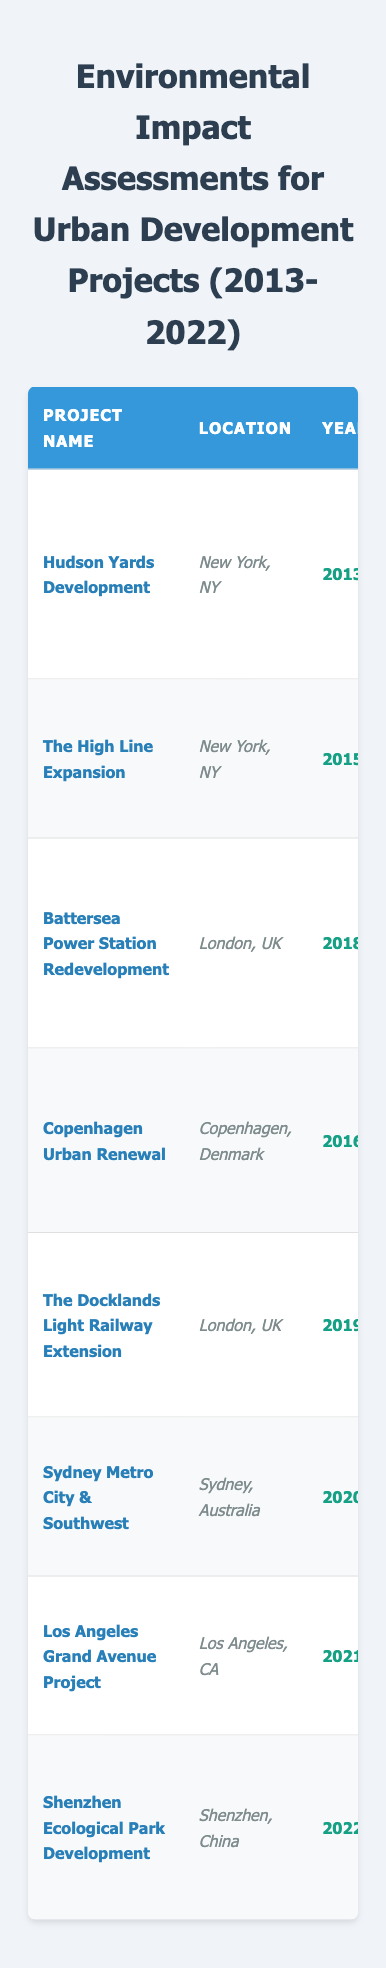What is the location of the Hudson Yards Development project? The table lists the location of each project in the 'Location' column. For the Hudson Yards Development, the location specified is New York, NY.
Answer: New York, NY How many projects assessed noise pollution? By scanning the 'Impact Area' column, I can count the occurrences of "Noise Pollution." This occurs for two projects: Battersea Power Station Redevelopment and Shenzhen Ecological Park Development.
Answer: 2 In which year was the Sydney Metro City & Southwest project completed? The 'Year' column provides the year of completion for each project. The Sydney Metro City & Southwest project was completed in 2020.
Answer: 2020 Did the High Line Expansion project involve public engagement? The 'Public Engagement' column describes the engagement for each project. The High Line Expansion did involve public engagement through an online feedback portal for residents.
Answer: Yes Which stakeholders were involved in the Battersea Power Station Redevelopment project? The 'Stakeholders Involved' column lists the participants for each project. For the Battersea Power Station Redevelopment, stakeholders involved are the Battersea Project Land Company and local government.
Answer: Battersea Project Land Company, local government What mitigation strategy was used in the Los Angeles Grand Avenue Project? The 'Mitigation Strategy' column outlines what strategies were implemented for each project. The strategy for the Los Angeles Grand Avenue Project was to develop a sight lines plan to minimize visual disruption.
Answer: Development of sight lines plan Which project assessment found that construction may lead to increased traffic congestion? The 'Assessment Findings' column indicates the outcomes related to each project. The Docklands Light Railway Extension project indicated improved public transport access but also potential increases in surrounding traffic.
Answer: The Docklands Light Railway Extension What is the total number of projects listed in the table? By counting the number of rows in the table after the header, I find that there are eight projects listed within the table.
Answer: 8 Which project was assessed for its impact on cultural heritage? The 'Impact Area' column lists the areas of impact for each project. The Sydney Metro City & Southwest project was the only project assessed for its impact on cultural heritage.
Answer: Sydney Metro City & Southwest Was there any community involvement reported for the Copenhagen Urban Renewal project? In reviewing the 'Public Engagement' column, it states that workshops were conducted to involve residents in design ideas for the Copenhagen Urban Renewal project, indicating community involvement.
Answer: Yes Which impact area dealt with visual impact due to construction? The table includes an 'Impact Area' column reflecting this factor. The Los Angeles Grand Avenue Project assessed the visual impact due to the construction of high-rise buildings.
Answer: Visual Impact 